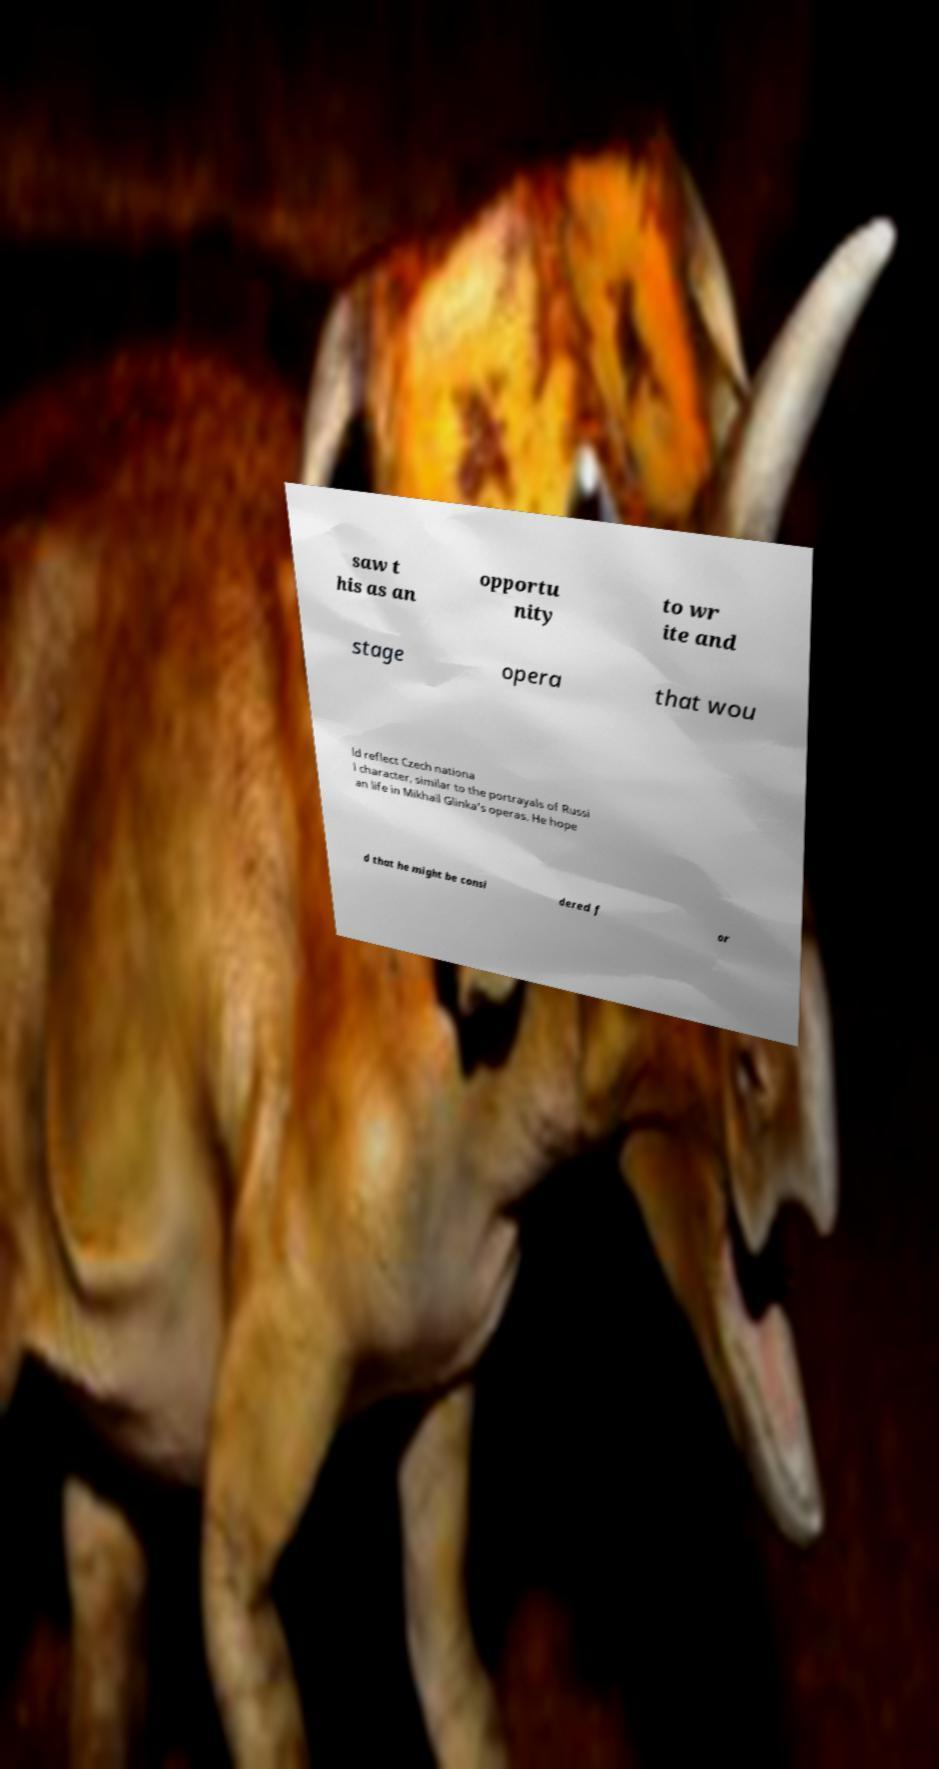Can you read and provide the text displayed in the image?This photo seems to have some interesting text. Can you extract and type it out for me? saw t his as an opportu nity to wr ite and stage opera that wou ld reflect Czech nationa l character, similar to the portrayals of Russi an life in Mikhail Glinka's operas. He hope d that he might be consi dered f or 